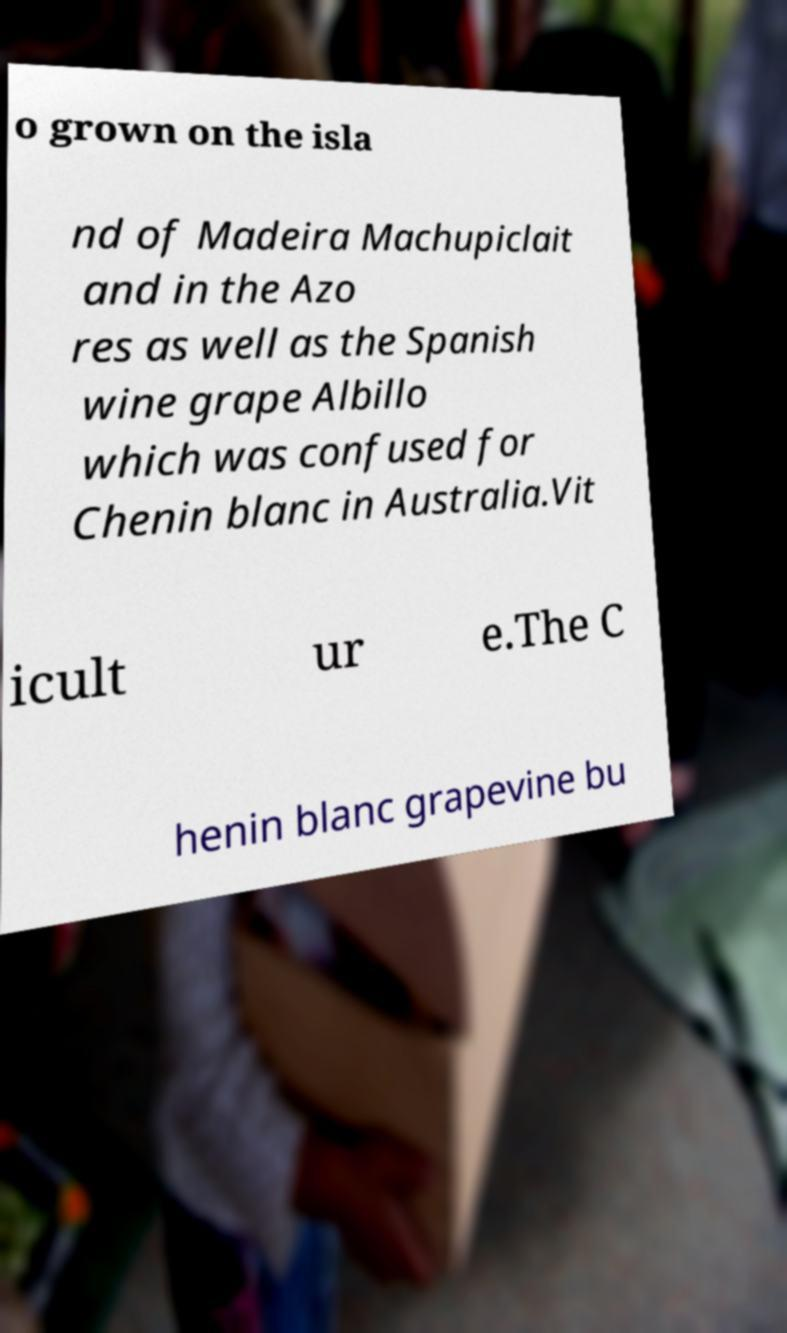Please read and relay the text visible in this image. What does it say? o grown on the isla nd of Madeira Machupiclait and in the Azo res as well as the Spanish wine grape Albillo which was confused for Chenin blanc in Australia.Vit icult ur e.The C henin blanc grapevine bu 